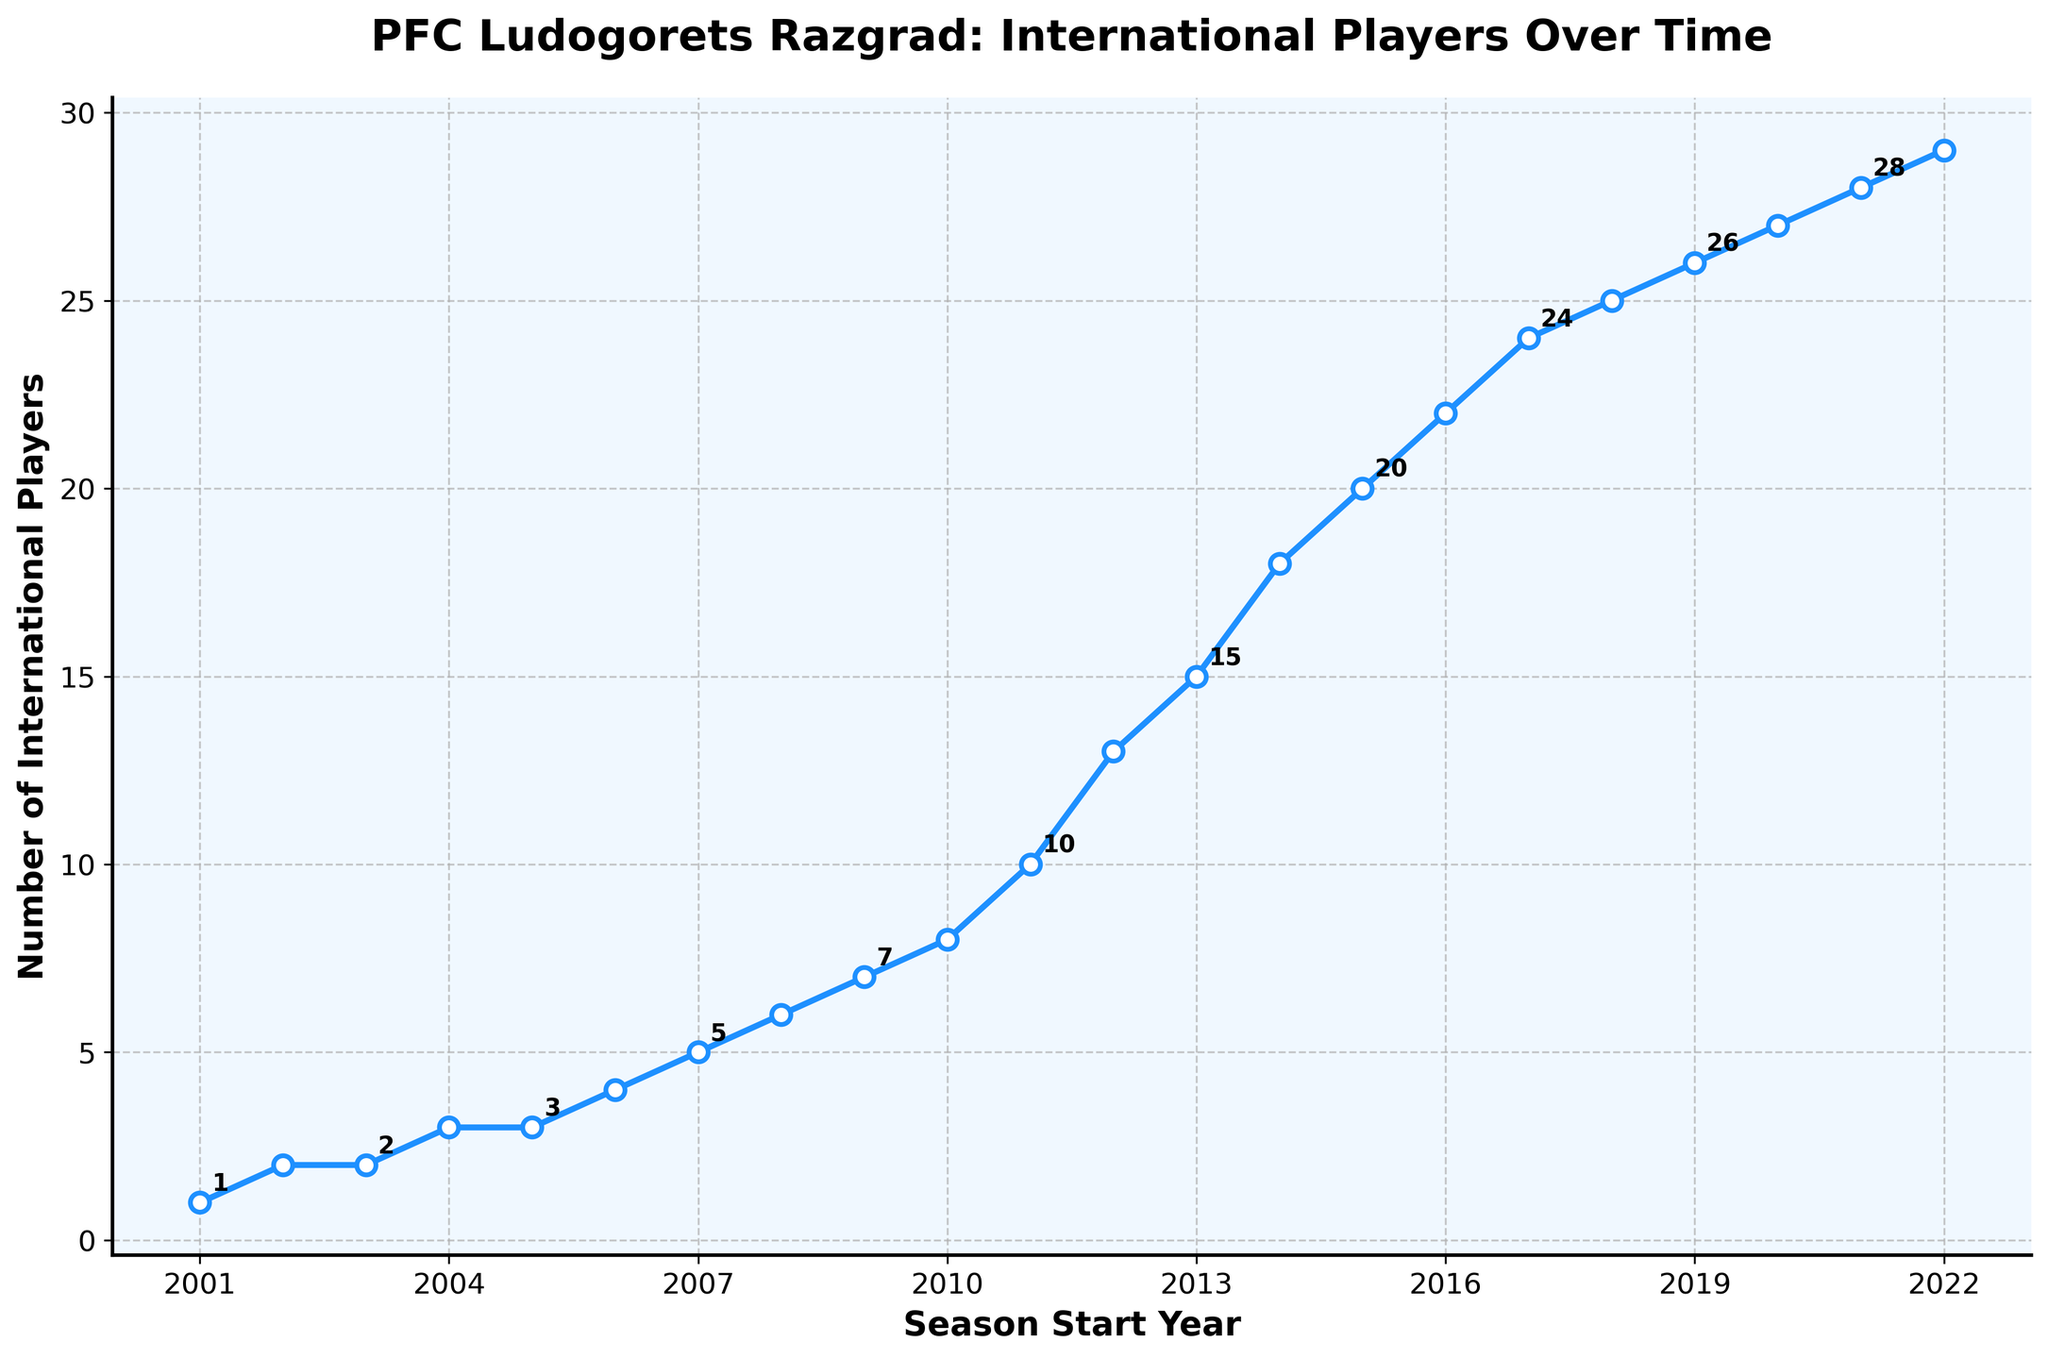How many international players were there at the beginning and end of the period shown in the graph? Identify the number of players in 2001-02 and 2022-23 seasons directly from the graph. In the 2001-02 season, there was 1 international player and in the 2022-23 season, there were 29.
Answer: 1 and 29 Which year did Ludogorets first surpass 20 international players on their squad? Look for the year where the number of international players first exceeds 20 by following the line graph upward. This occurs in the 2015-16 season when the number reaches 20.
Answer: 2015-16 Did the number of international players increase every season? Check the line for any horizontal segments or downward slopes. By observing, the number increases every season without decrease or plateau.
Answer: Yes In which season did Ludogorets see the most significant increase in international players? Determine the largest vertical jump between consecutive points on the graph. The largest jump is between 2011-12 (10 players) and 2012-13 (13 players), which is an increase of 3 players.
Answer: 2012-13 What was the average number of international players during the last 5 seasons shown? Identify the number of players for the last 5 seasons: 25 (2018-19), 26 (2019-20), 27 (2020-21), 28 (2021-22), and 29 (2022-23). Calculate the average: (25 + 26 + 27 + 28 + 29) / 5 = 27.
Answer: 27 What is the total increase in the number of international players from the 2010-11 season to the 2022-23 season? Subtract the number of players in 2010-11 from those in 2022-23. The number of players in 2010-11 is 8 and in 2022-23 is 29. Thus, 29 - 8 = 21.
Answer: 21 How does the number of international players in the 2006-07 season compare to that in the 2012-13 season? Compare the values on the y-axis directly from the figure. There are 4 players in 2006-07 and 13 players in 2012-13. 13 is greater than 4.
Answer: Greater in 2012-13 What is the median number of international players over all the seasons shown? List all the values: [1, 2, 2, 3, 3, 4, 5, 6, 7, 8, 10, 13, 15, 18, 20, 22, 24, 25, 26, 27, 28, 29]. The median is the middle value: (10 + 13) / 2 = 11.5.
Answer: 11.5 In how many seasons did the number of international players reach double digits? Identify seasons with 10 or more players from the graph: 2011-12 onwards. Count the seasons: 2011-12 to 2022-23, which totals 12 seasons.
Answer: 12 Which seasons show an even number of international players? List seasons with even values from the figure: These are 2002-03 (2), 2003-04 (2), 2004-05 (2), 2005-06 (2), 2006-07 (2), 2008-09 (6), 2009-10 (6), 2010-11 (8), 2012-13 (13), 2014-15 (18), 2016-17 (22), 2018-19 (25), 2020-21 (27), 2022-23 (29). Count them, which results in 7 seasons.
Answer: 7 